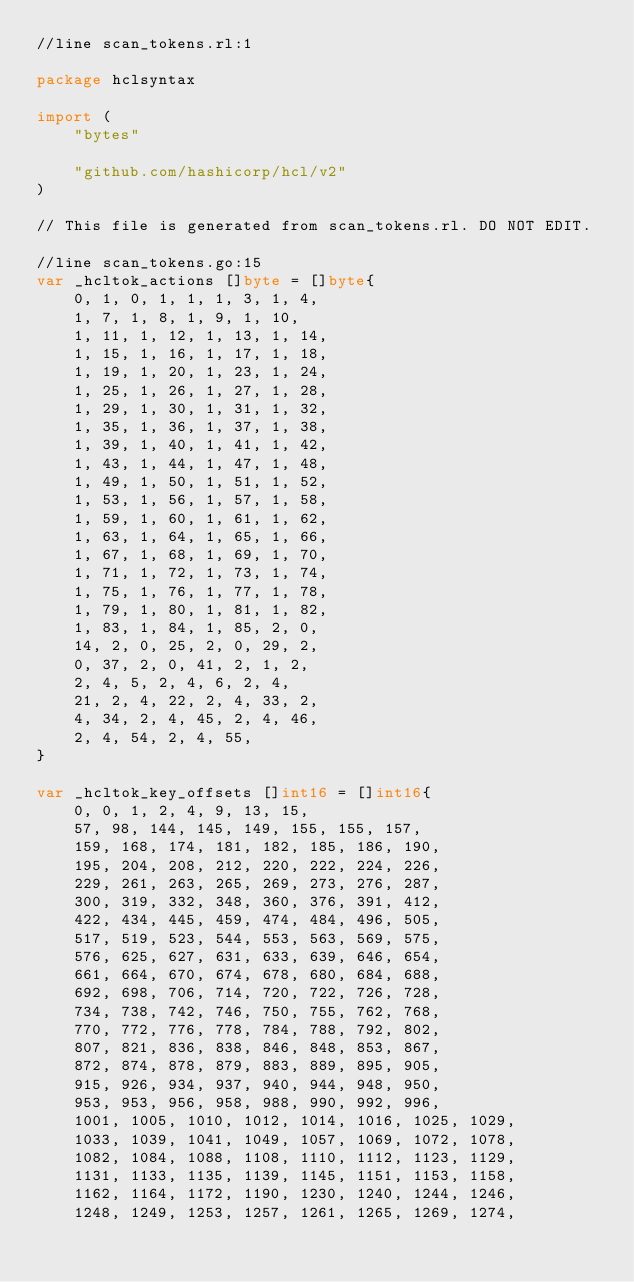Convert code to text. <code><loc_0><loc_0><loc_500><loc_500><_Go_>//line scan_tokens.rl:1

package hclsyntax

import (
	"bytes"

	"github.com/hashicorp/hcl/v2"
)

// This file is generated from scan_tokens.rl. DO NOT EDIT.

//line scan_tokens.go:15
var _hcltok_actions []byte = []byte{
	0, 1, 0, 1, 1, 1, 3, 1, 4,
	1, 7, 1, 8, 1, 9, 1, 10,
	1, 11, 1, 12, 1, 13, 1, 14,
	1, 15, 1, 16, 1, 17, 1, 18,
	1, 19, 1, 20, 1, 23, 1, 24,
	1, 25, 1, 26, 1, 27, 1, 28,
	1, 29, 1, 30, 1, 31, 1, 32,
	1, 35, 1, 36, 1, 37, 1, 38,
	1, 39, 1, 40, 1, 41, 1, 42,
	1, 43, 1, 44, 1, 47, 1, 48,
	1, 49, 1, 50, 1, 51, 1, 52,
	1, 53, 1, 56, 1, 57, 1, 58,
	1, 59, 1, 60, 1, 61, 1, 62,
	1, 63, 1, 64, 1, 65, 1, 66,
	1, 67, 1, 68, 1, 69, 1, 70,
	1, 71, 1, 72, 1, 73, 1, 74,
	1, 75, 1, 76, 1, 77, 1, 78,
	1, 79, 1, 80, 1, 81, 1, 82,
	1, 83, 1, 84, 1, 85, 2, 0,
	14, 2, 0, 25, 2, 0, 29, 2,
	0, 37, 2, 0, 41, 2, 1, 2,
	2, 4, 5, 2, 4, 6, 2, 4,
	21, 2, 4, 22, 2, 4, 33, 2,
	4, 34, 2, 4, 45, 2, 4, 46,
	2, 4, 54, 2, 4, 55,
}

var _hcltok_key_offsets []int16 = []int16{
	0, 0, 1, 2, 4, 9, 13, 15,
	57, 98, 144, 145, 149, 155, 155, 157,
	159, 168, 174, 181, 182, 185, 186, 190,
	195, 204, 208, 212, 220, 222, 224, 226,
	229, 261, 263, 265, 269, 273, 276, 287,
	300, 319, 332, 348, 360, 376, 391, 412,
	422, 434, 445, 459, 474, 484, 496, 505,
	517, 519, 523, 544, 553, 563, 569, 575,
	576, 625, 627, 631, 633, 639, 646, 654,
	661, 664, 670, 674, 678, 680, 684, 688,
	692, 698, 706, 714, 720, 722, 726, 728,
	734, 738, 742, 746, 750, 755, 762, 768,
	770, 772, 776, 778, 784, 788, 792, 802,
	807, 821, 836, 838, 846, 848, 853, 867,
	872, 874, 878, 879, 883, 889, 895, 905,
	915, 926, 934, 937, 940, 944, 948, 950,
	953, 953, 956, 958, 988, 990, 992, 996,
	1001, 1005, 1010, 1012, 1014, 1016, 1025, 1029,
	1033, 1039, 1041, 1049, 1057, 1069, 1072, 1078,
	1082, 1084, 1088, 1108, 1110, 1112, 1123, 1129,
	1131, 1133, 1135, 1139, 1145, 1151, 1153, 1158,
	1162, 1164, 1172, 1190, 1230, 1240, 1244, 1246,
	1248, 1249, 1253, 1257, 1261, 1265, 1269, 1274,</code> 